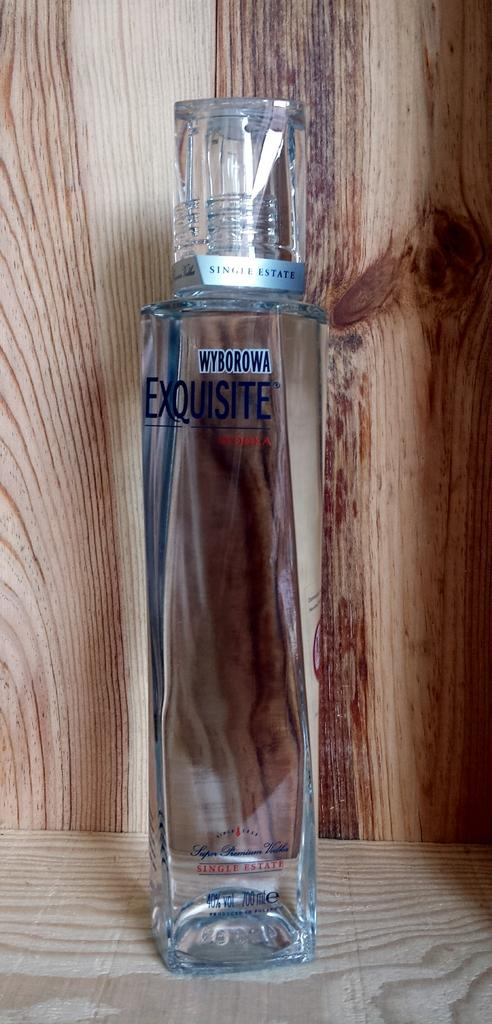<image>
Describe the image concisely. A clear bottle of Wyborowa vodka with blue lettering on a wood surface. 